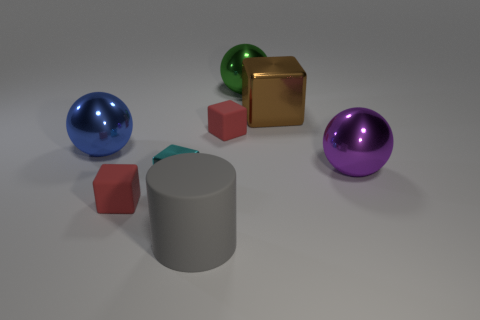Are the red block on the left side of the gray rubber thing and the blue sphere made of the same material?
Make the answer very short. No. What number of other things are there of the same shape as the tiny metallic object?
Keep it short and to the point. 3. Is the shape of the cyan shiny object in front of the large purple metal ball the same as the tiny rubber thing that is to the left of the big gray matte cylinder?
Provide a short and direct response. Yes. Are there an equal number of cyan objects that are right of the gray cylinder and matte blocks that are to the right of the purple metal sphere?
Offer a terse response. Yes. There is a red matte thing that is in front of the large metal thing that is in front of the big metal object on the left side of the large cylinder; what is its shape?
Make the answer very short. Cube. Do the large ball on the left side of the gray matte cylinder and the red cube left of the large rubber object have the same material?
Provide a short and direct response. No. There is a red object right of the big matte cylinder; what is its shape?
Provide a succinct answer. Cube. Are there any matte cylinders on the left side of the rubber cube that is in front of the large object right of the big brown metal block?
Your answer should be very brief. No. Is the color of the big matte object the same as the small metallic cube?
Your answer should be compact. No. There is a blue thing; how many small rubber objects are behind it?
Make the answer very short. 1. 